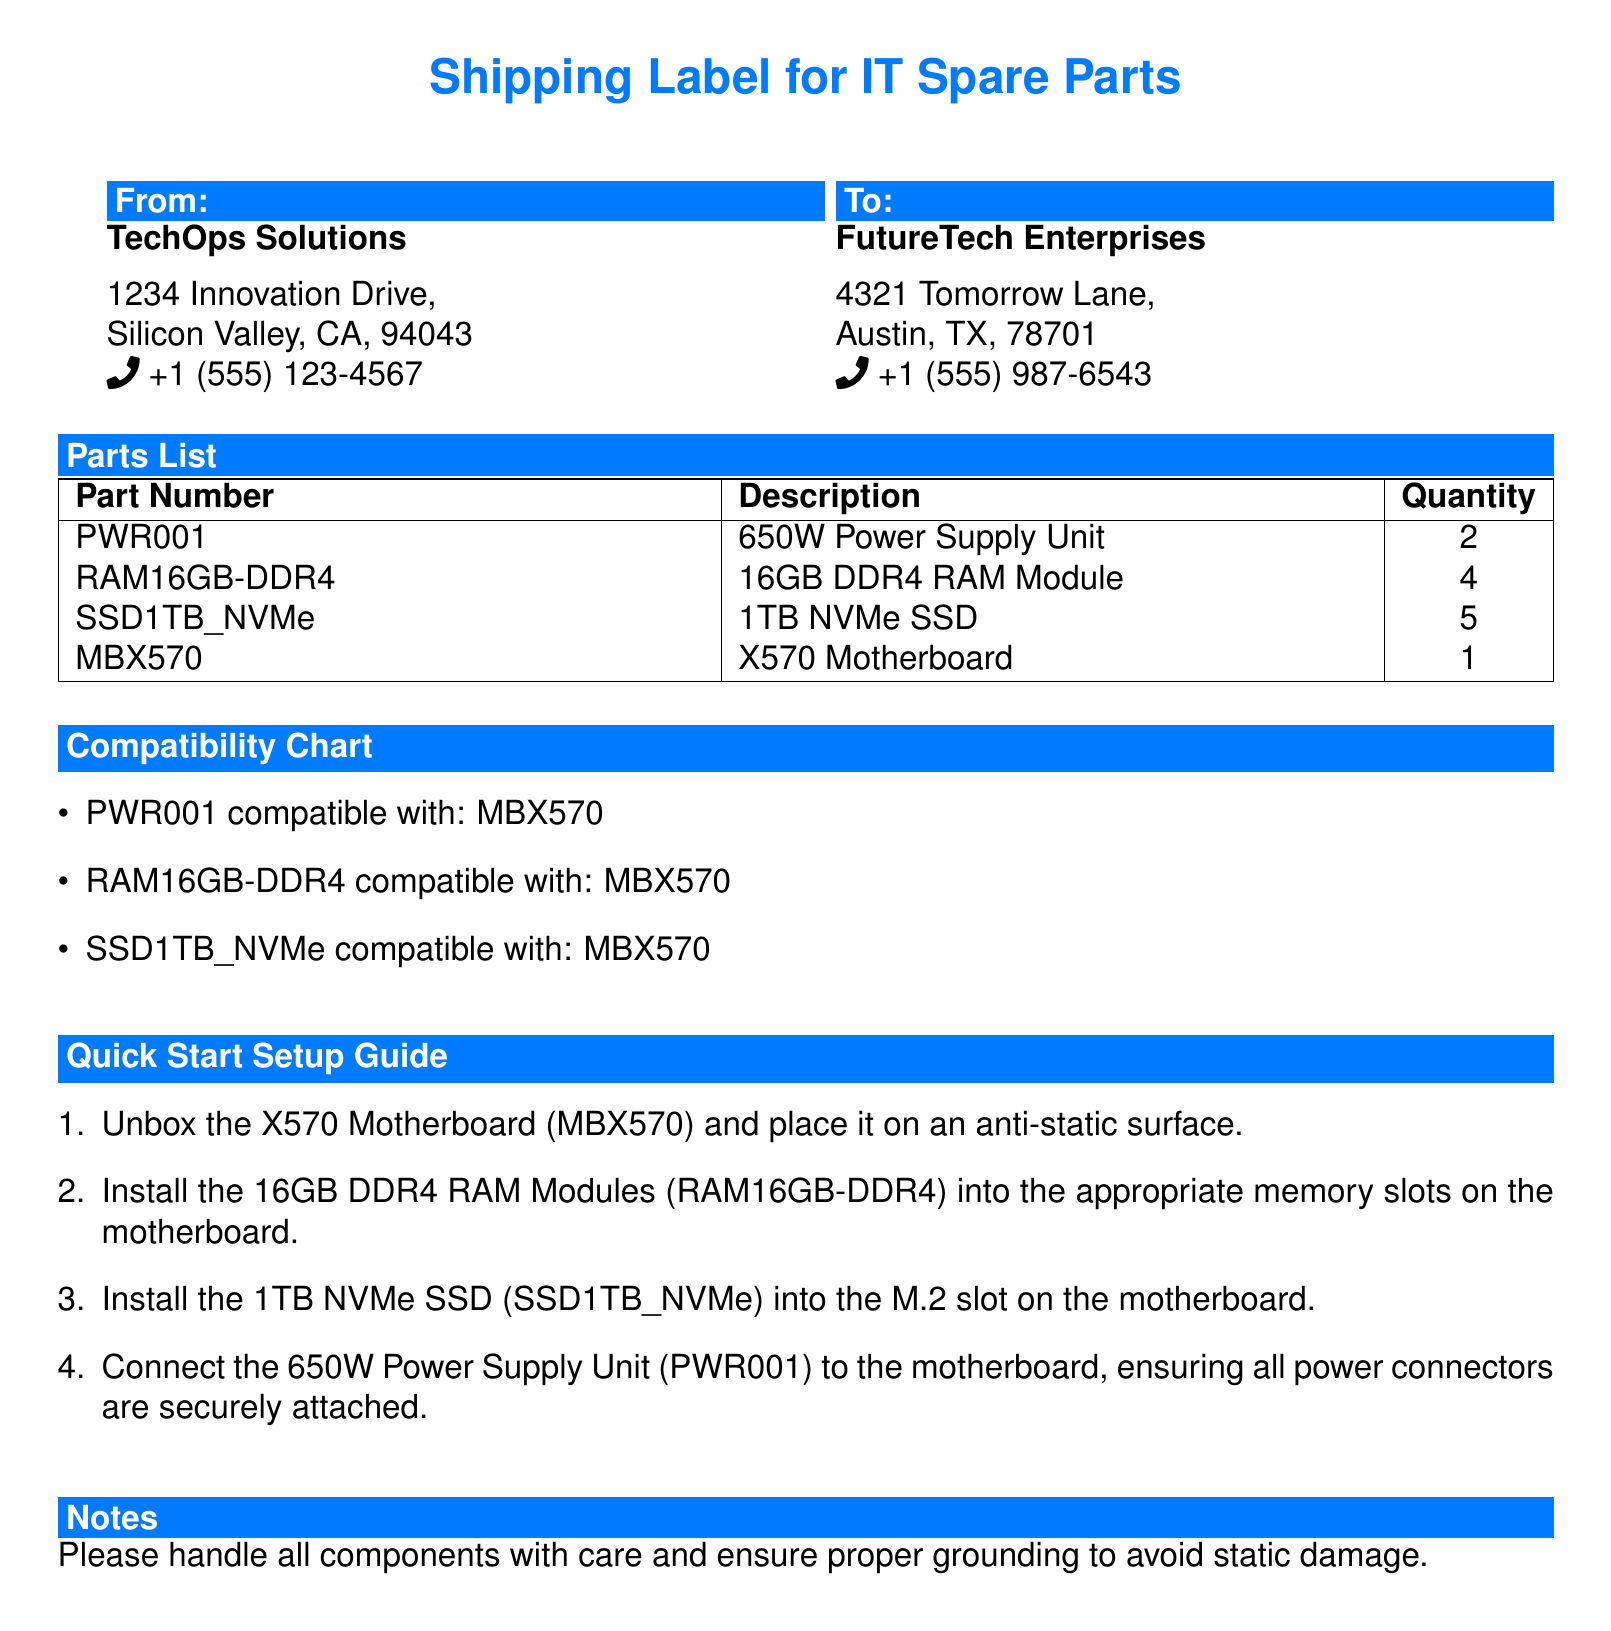What is the total quantity of 16GB DDR4 RAM Modules? The quantity is directly listed in the Parts List section under the description for RAM16GB-DDR4, which states it is 4.
Answer: 4 Who is the sender of the shipping label? The sender's name, TechOps Solutions, is located in the From section of the document.
Answer: TechOps Solutions Which part is installed in the M.2 slot on the motherboard? The Quick Start Setup Guide indicates that SSD1TB_NVMe is to be installed in the M.2 slot on the motherboard.
Answer: 1TB NVMe SSD How many components are listed in the Parts List? By counting the entries in the Parts List table, there are 4 items listed.
Answer: 4 What does the acronym MBX570 refer to? MBX570 is identified in the document as the X570 Motherboard, as stated in the Parts List and Compatibility Chart.
Answer: X570 Motherboard Which part is compatible with all listed components? The Compatibility Chart specifies MBX570 as being compatible with the other listed parts.
Answer: MBX570 What is the first step in the Quick Start Setup Guide? The first step listed is to unbox the X570 Motherboard (MBX570) and place it on an anti-static surface.
Answer: Unbox the X570 Motherboard What is the contact phone number for FutureTech Enterprises? The phone number appears in the To section, provided next to FutureTech Enterprises.
Answer: +1 (555) 987-6543 How many 650W Power Supply Units are included in the shipment? The shipment includes 2 units, as stated in the Parts List section.
Answer: 2 